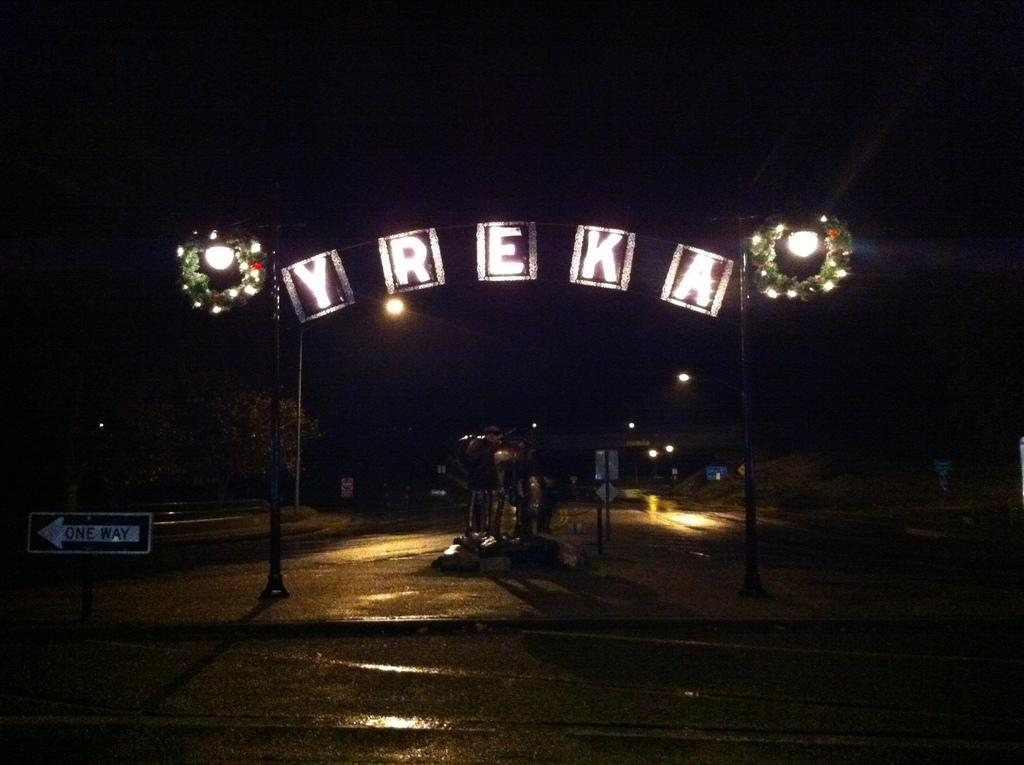What is the main feature in the middle of the image? There are letters and lights arranged in the middle of the image. Can you describe the lights in the background of the image? There are lights in the background of the image. What is the color of the background in the image? The background of the image is dark in color. What type of meat can be seen hanging from the letters in the image? There is no meat present in the image; it features an arrangement of letters and lights. How many kittens are playing with the rice in the image? There are no kittens or rice present in the image. 